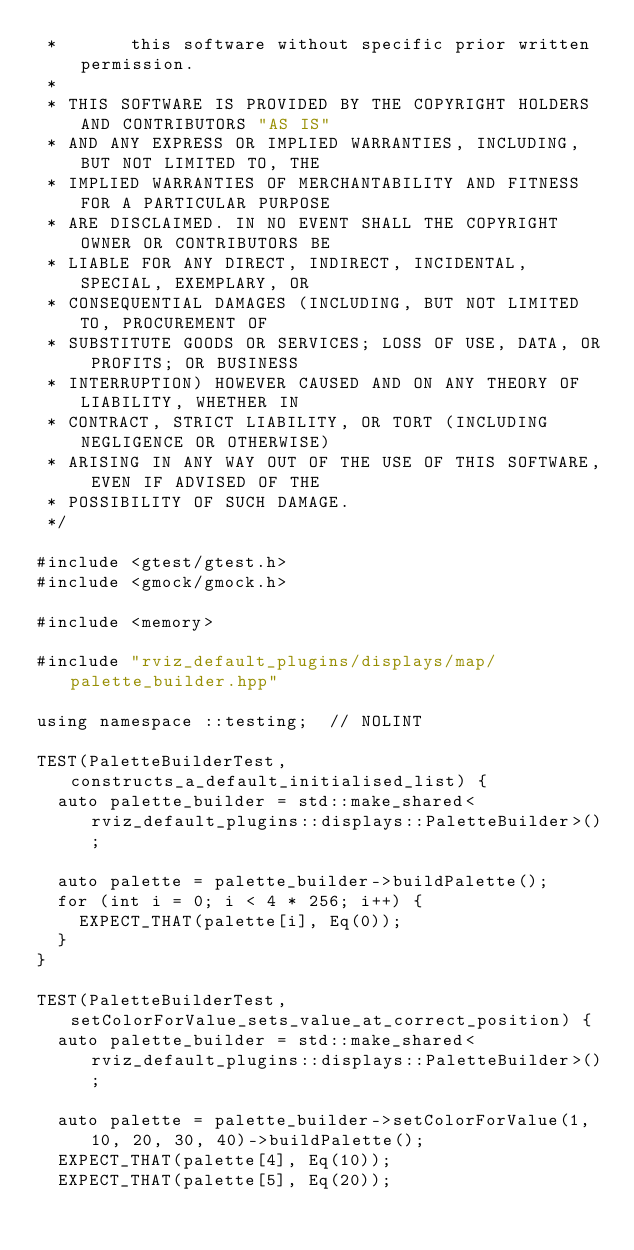Convert code to text. <code><loc_0><loc_0><loc_500><loc_500><_C++_> *       this software without specific prior written permission.
 *
 * THIS SOFTWARE IS PROVIDED BY THE COPYRIGHT HOLDERS AND CONTRIBUTORS "AS IS"
 * AND ANY EXPRESS OR IMPLIED WARRANTIES, INCLUDING, BUT NOT LIMITED TO, THE
 * IMPLIED WARRANTIES OF MERCHANTABILITY AND FITNESS FOR A PARTICULAR PURPOSE
 * ARE DISCLAIMED. IN NO EVENT SHALL THE COPYRIGHT OWNER OR CONTRIBUTORS BE
 * LIABLE FOR ANY DIRECT, INDIRECT, INCIDENTAL, SPECIAL, EXEMPLARY, OR
 * CONSEQUENTIAL DAMAGES (INCLUDING, BUT NOT LIMITED TO, PROCUREMENT OF
 * SUBSTITUTE GOODS OR SERVICES; LOSS OF USE, DATA, OR PROFITS; OR BUSINESS
 * INTERRUPTION) HOWEVER CAUSED AND ON ANY THEORY OF LIABILITY, WHETHER IN
 * CONTRACT, STRICT LIABILITY, OR TORT (INCLUDING NEGLIGENCE OR OTHERWISE)
 * ARISING IN ANY WAY OUT OF THE USE OF THIS SOFTWARE, EVEN IF ADVISED OF THE
 * POSSIBILITY OF SUCH DAMAGE.
 */

#include <gtest/gtest.h>
#include <gmock/gmock.h>

#include <memory>

#include "rviz_default_plugins/displays/map/palette_builder.hpp"

using namespace ::testing;  // NOLINT

TEST(PaletteBuilderTest, constructs_a_default_initialised_list) {
  auto palette_builder = std::make_shared<rviz_default_plugins::displays::PaletteBuilder>();

  auto palette = palette_builder->buildPalette();
  for (int i = 0; i < 4 * 256; i++) {
    EXPECT_THAT(palette[i], Eq(0));
  }
}

TEST(PaletteBuilderTest, setColorForValue_sets_value_at_correct_position) {
  auto palette_builder = std::make_shared<rviz_default_plugins::displays::PaletteBuilder>();

  auto palette = palette_builder->setColorForValue(1, 10, 20, 30, 40)->buildPalette();
  EXPECT_THAT(palette[4], Eq(10));
  EXPECT_THAT(palette[5], Eq(20));</code> 